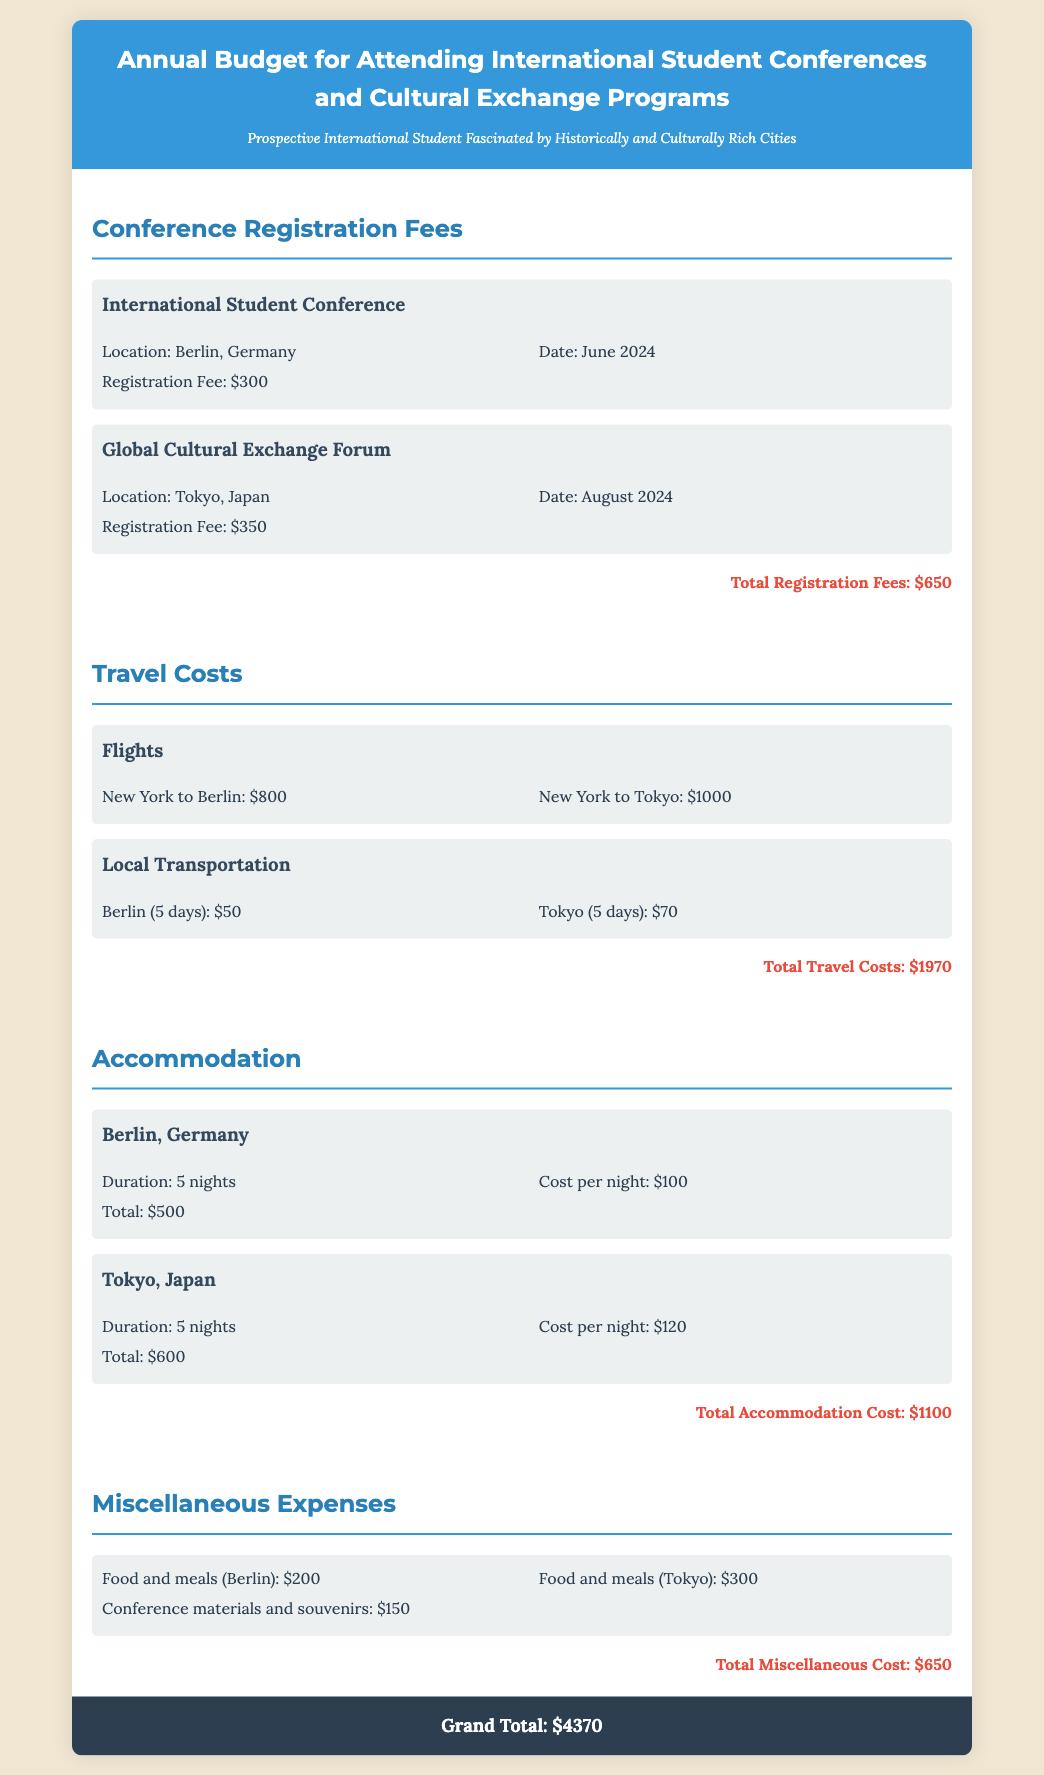what is the registration fee for the International Student Conference? The registration fee for the International Student Conference located in Berlin is listed in the document.
Answer: $300 what is the total travel cost? The total travel cost is the sum of all flight and local transportation expenses detailed in the budget.
Answer: $1970 how many nights will be spent in Tokyo? The duration of stay in Tokyo, as specified in the accommodation section, indicates the number of nights.
Answer: 5 nights what is the total accommodation cost? The total accommodation cost is calculated by adding the accommodation expenses for both Berlin and Tokyo.
Answer: $1100 where is the Global Cultural Exchange Forum located? The location of the Global Cultural Exchange Forum is mentioned in the document.
Answer: Tokyo, Japan what is the grand total budget for the entire trip? The grand total budget is the aggregate of all expenses listed throughout the document, including registration, travel, accommodation, and miscellaneous costs.
Answer: $4370 what is the registration fee for the Global Cultural Exchange Forum? The registration fee for the Global Cultural Exchange Forum is clearly stated in the budget details.
Answer: $350 how much is allocated for food and meals in Berlin? The amount allocated for food and meals in Berlin is specified among the miscellaneous expenses in the budget.
Answer: $200 what is the cost per night for accommodation in Tokyo? The cost per night for accommodation in Tokyo is detailed in the accommodation section of the document.
Answer: $120 